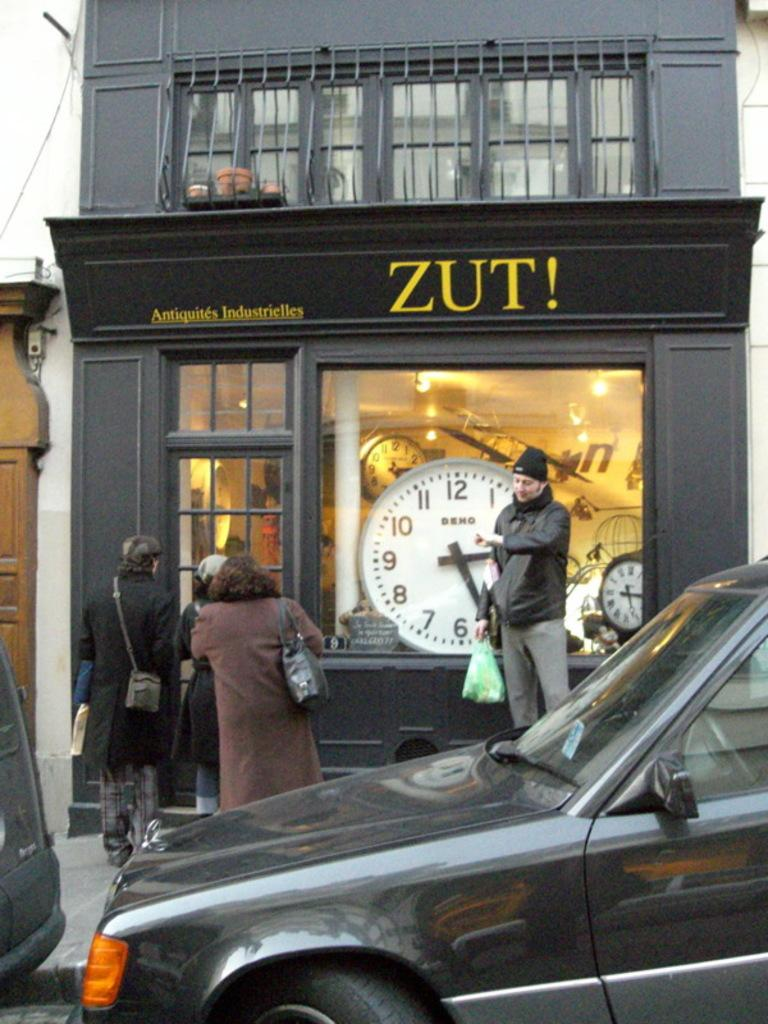What can be seen on the right side of the image? There is a car parked on the right side of the image. What is located in the middle of the image? There is a watch store in the middle of the image. What are the people near the watch store doing? The people standing near the watch store are looking at the watch store. What type of education can be seen in the image? There is no reference to education in the image; it features a car, a watch store, and people looking at the store. How does the car control the traffic in the image? The car is parked and not controlling traffic in the image. 